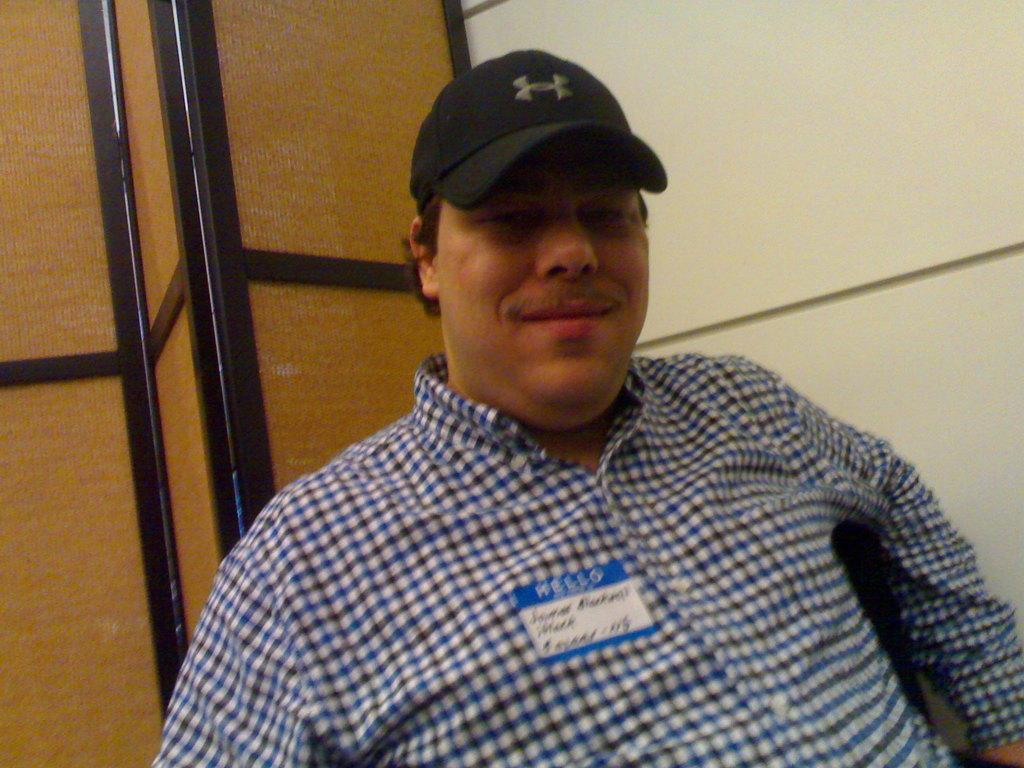Who is present in the image? There is a man in the picture. What is the man doing in the image? The man is sitting in the front and giving a pose. What is the man's facial expression in the image? The man is smiling in the image. What can be seen in the background of the image? There is a yellow color wall and brown doors in the background. What type of sofa can be seen in the image? There is no sofa present in the image. 